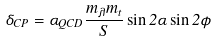Convert formula to latex. <formula><loc_0><loc_0><loc_500><loc_500>\delta _ { C P } = \alpha _ { Q C D } \frac { m _ { \lambda } m _ { t } } { S } \sin 2 \alpha \sin 2 \phi</formula> 